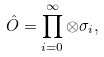Convert formula to latex. <formula><loc_0><loc_0><loc_500><loc_500>\hat { O } = \prod _ { i = 0 } ^ { \infty } \otimes \sigma _ { i } ,</formula> 